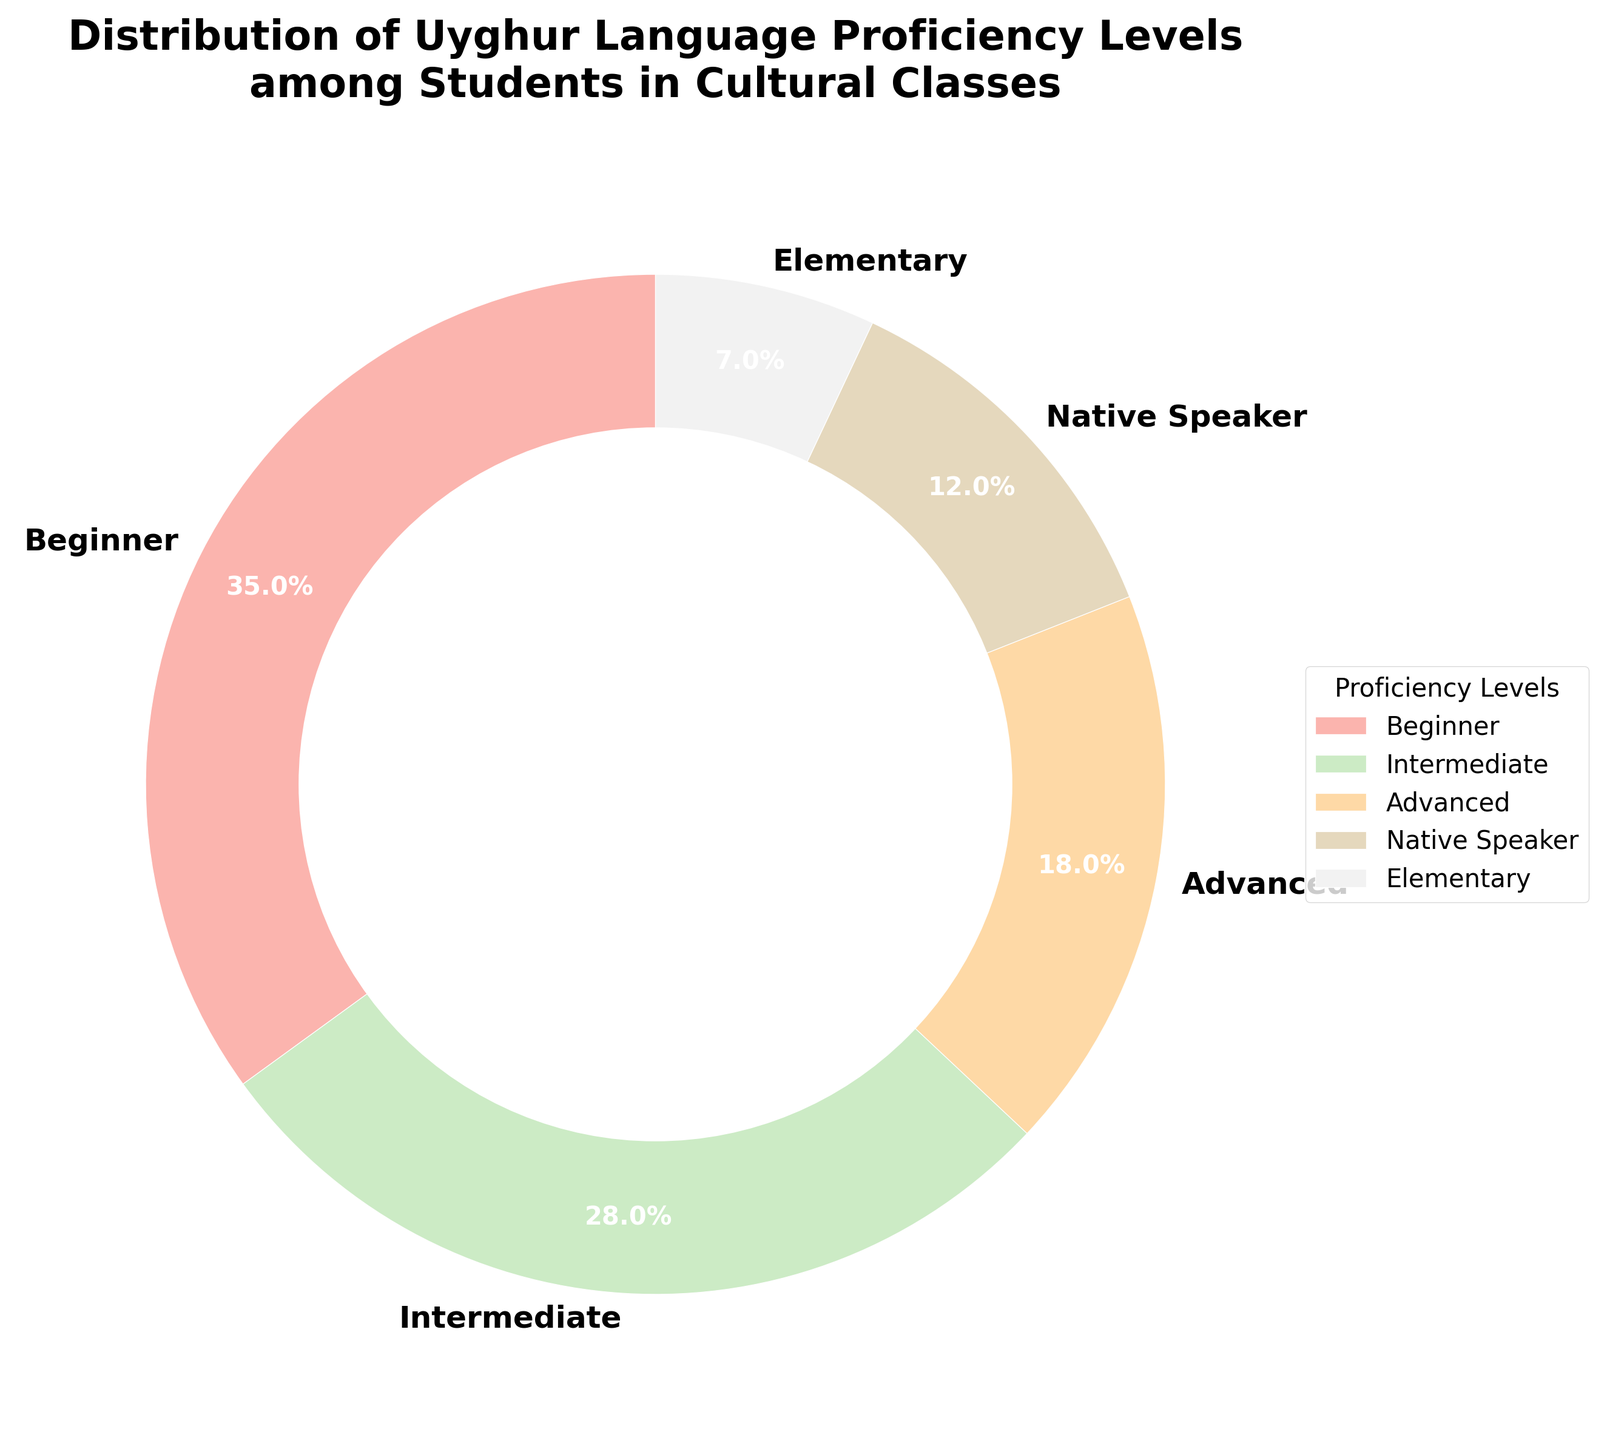What's the most common language proficiency level? The pie chart shows the distribution of different proficiency levels. The largest slice representing 35% is for "Beginner".
Answer: Beginner What's the sum of the percentages for Advanced and Native Speaker levels? By looking at the pie chart, Advanced levels account for 18% and Native Speaker levels account for 12%. Adding them together: 18% + 12% = 30%.
Answer: 30% Which proficiency level represents the smallest group? Referring to the pie chart, the smallest segment shows the "Elementary" level at 7%.
Answer: Elementary What is the percentage difference between Beginner and Intermediate levels? According to the chart, Beginner levels are 35% and Intermediate levels are 28%. The difference is 35% - 28% = 7%.
Answer: 7% Which two proficiency levels together make up the majority of students? Observing the chart, Beginner and Intermediate levels are the largest groups at 35% and 28%, respectively. Together, they sum up to 35% + 28% = 63%, which is more than half.
Answer: Beginner and Intermediate What percentage of students are at least at an Intermediate level? Summing the percentages for Intermediate (28%), Advanced (18%), and Native Speaker (12%): 28% + 18% + 12% = 58%.
Answer: 58% Which proficiency level is the third most common? From the pie chart, the third largest slice, after Beginner (35%) and Intermediate (28%), is Advanced at 18%.
Answer: Advanced Are there more students at Elementary or Native Speaker levels, and how many more? Native Speaker levels account for 12% and Elementary levels account for 7%. The difference is 12% - 7% = 5%. Native Speaker levels have 5% more students than Elementary levels.
Answer: Native Speaker levels by 5% How much more common is the Beginner level compared to the Advanced level? The pie chart indicates that the Beginner level is at 35% and the Advanced level is at 18%. The difference is 35% - 18% = 17%.
Answer: 17% If you combine students at Beginner and Advanced levels, what fraction of the total student population do they represent? Adding the Beginner (35%) and Advanced (18%) levels, we get 35% + 18% = 53%.
Answer: 53% 